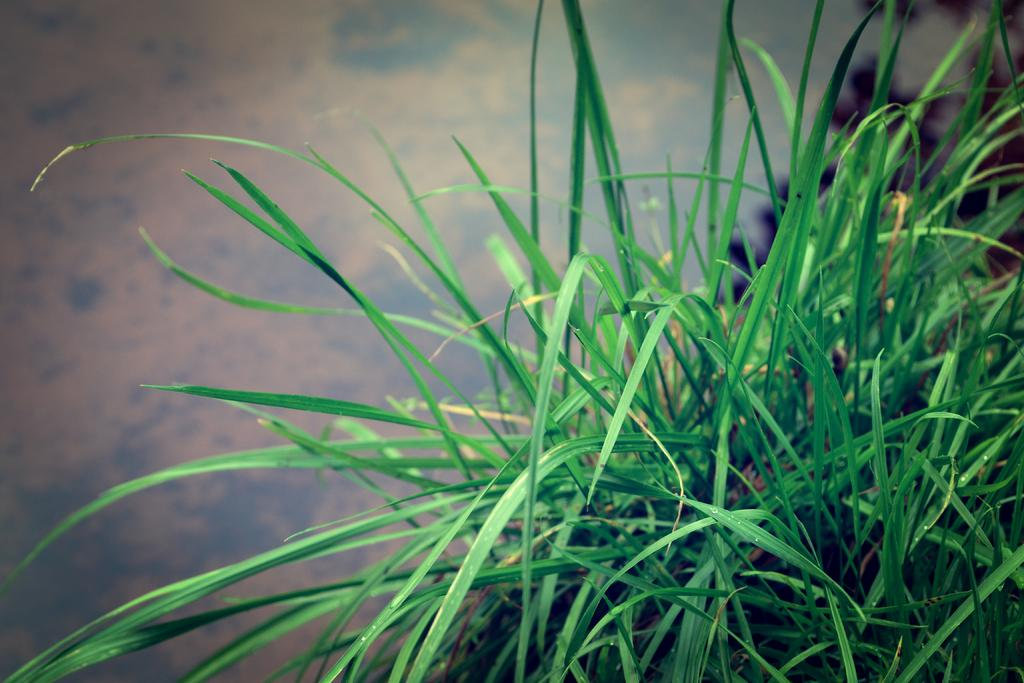What type of living organisms can be seen in the image? Plants can be seen in the image. What color are the leaves of the plants in the image? The leaves of the plants in the image are green. Can you describe the background of the image? The background of the image appears blurry. What type of salt can be seen on the leaves of the plants in the image? There is no salt visible on the leaves of the plants in the image. What rhythm do the plants follow in the image? Plants do not follow a rhythm; they are stationary living organisms. 